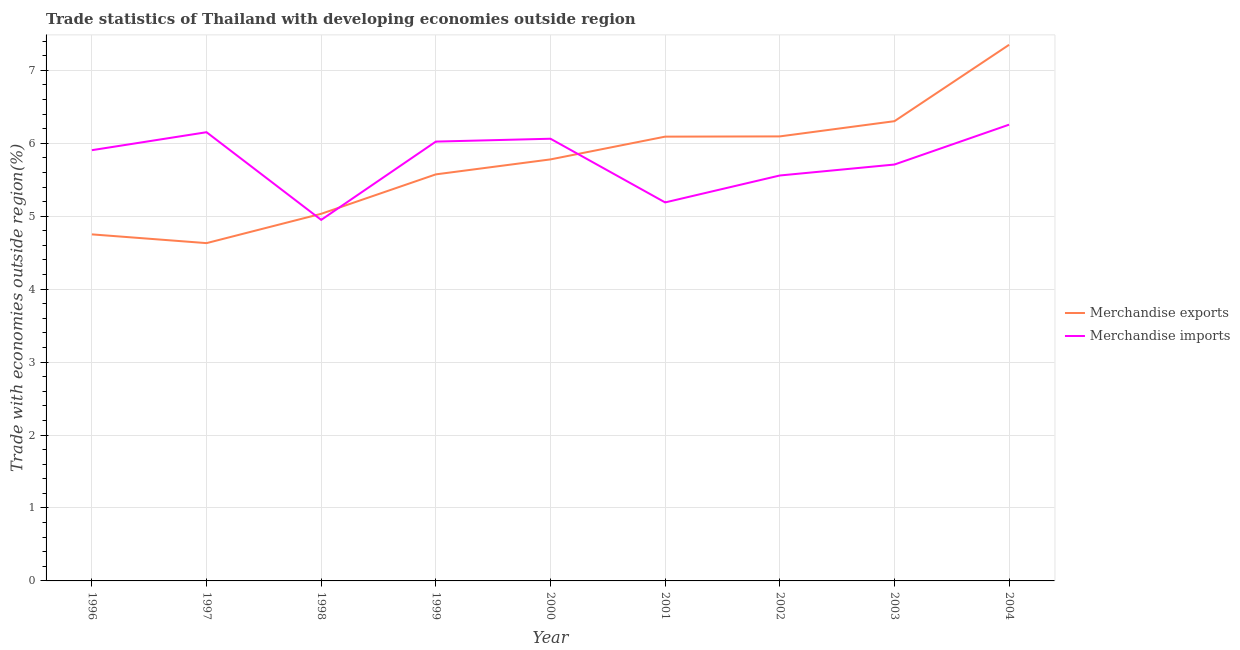How many different coloured lines are there?
Provide a short and direct response. 2. What is the merchandise exports in 2003?
Offer a terse response. 6.3. Across all years, what is the maximum merchandise exports?
Keep it short and to the point. 7.35. Across all years, what is the minimum merchandise imports?
Your response must be concise. 4.95. In which year was the merchandise imports maximum?
Your answer should be very brief. 2004. What is the total merchandise imports in the graph?
Your answer should be compact. 51.8. What is the difference between the merchandise imports in 1998 and that in 2001?
Ensure brevity in your answer.  -0.24. What is the difference between the merchandise exports in 1998 and the merchandise imports in 2000?
Give a very brief answer. -1.03. What is the average merchandise exports per year?
Make the answer very short. 5.73. In the year 2002, what is the difference between the merchandise exports and merchandise imports?
Provide a succinct answer. 0.54. In how many years, is the merchandise exports greater than 0.8 %?
Ensure brevity in your answer.  9. What is the ratio of the merchandise exports in 1996 to that in 1999?
Offer a terse response. 0.85. What is the difference between the highest and the second highest merchandise imports?
Keep it short and to the point. 0.1. What is the difference between the highest and the lowest merchandise imports?
Keep it short and to the point. 1.31. In how many years, is the merchandise imports greater than the average merchandise imports taken over all years?
Ensure brevity in your answer.  5. Is the sum of the merchandise exports in 1996 and 2003 greater than the maximum merchandise imports across all years?
Provide a succinct answer. Yes. Does the merchandise imports monotonically increase over the years?
Ensure brevity in your answer.  No. Is the merchandise exports strictly greater than the merchandise imports over the years?
Your response must be concise. No. Are the values on the major ticks of Y-axis written in scientific E-notation?
Provide a short and direct response. No. What is the title of the graph?
Your response must be concise. Trade statistics of Thailand with developing economies outside region. What is the label or title of the X-axis?
Offer a terse response. Year. What is the label or title of the Y-axis?
Your answer should be compact. Trade with economies outside region(%). What is the Trade with economies outside region(%) in Merchandise exports in 1996?
Provide a succinct answer. 4.75. What is the Trade with economies outside region(%) in Merchandise imports in 1996?
Your response must be concise. 5.91. What is the Trade with economies outside region(%) of Merchandise exports in 1997?
Keep it short and to the point. 4.63. What is the Trade with economies outside region(%) in Merchandise imports in 1997?
Provide a succinct answer. 6.15. What is the Trade with economies outside region(%) in Merchandise exports in 1998?
Provide a short and direct response. 5.03. What is the Trade with economies outside region(%) in Merchandise imports in 1998?
Your answer should be very brief. 4.95. What is the Trade with economies outside region(%) in Merchandise exports in 1999?
Your response must be concise. 5.57. What is the Trade with economies outside region(%) of Merchandise imports in 1999?
Your response must be concise. 6.02. What is the Trade with economies outside region(%) in Merchandise exports in 2000?
Make the answer very short. 5.78. What is the Trade with economies outside region(%) of Merchandise imports in 2000?
Ensure brevity in your answer.  6.06. What is the Trade with economies outside region(%) in Merchandise exports in 2001?
Keep it short and to the point. 6.09. What is the Trade with economies outside region(%) of Merchandise imports in 2001?
Offer a terse response. 5.19. What is the Trade with economies outside region(%) of Merchandise exports in 2002?
Offer a terse response. 6.09. What is the Trade with economies outside region(%) of Merchandise imports in 2002?
Your answer should be compact. 5.56. What is the Trade with economies outside region(%) of Merchandise exports in 2003?
Offer a very short reply. 6.3. What is the Trade with economies outside region(%) of Merchandise imports in 2003?
Make the answer very short. 5.71. What is the Trade with economies outside region(%) in Merchandise exports in 2004?
Ensure brevity in your answer.  7.35. What is the Trade with economies outside region(%) in Merchandise imports in 2004?
Your answer should be very brief. 6.25. Across all years, what is the maximum Trade with economies outside region(%) in Merchandise exports?
Keep it short and to the point. 7.35. Across all years, what is the maximum Trade with economies outside region(%) in Merchandise imports?
Your answer should be very brief. 6.25. Across all years, what is the minimum Trade with economies outside region(%) in Merchandise exports?
Offer a terse response. 4.63. Across all years, what is the minimum Trade with economies outside region(%) of Merchandise imports?
Provide a succinct answer. 4.95. What is the total Trade with economies outside region(%) in Merchandise exports in the graph?
Provide a succinct answer. 51.61. What is the total Trade with economies outside region(%) of Merchandise imports in the graph?
Provide a short and direct response. 51.8. What is the difference between the Trade with economies outside region(%) of Merchandise exports in 1996 and that in 1997?
Offer a terse response. 0.12. What is the difference between the Trade with economies outside region(%) in Merchandise imports in 1996 and that in 1997?
Your response must be concise. -0.25. What is the difference between the Trade with economies outside region(%) in Merchandise exports in 1996 and that in 1998?
Make the answer very short. -0.28. What is the difference between the Trade with economies outside region(%) in Merchandise imports in 1996 and that in 1998?
Ensure brevity in your answer.  0.96. What is the difference between the Trade with economies outside region(%) in Merchandise exports in 1996 and that in 1999?
Keep it short and to the point. -0.82. What is the difference between the Trade with economies outside region(%) of Merchandise imports in 1996 and that in 1999?
Give a very brief answer. -0.12. What is the difference between the Trade with economies outside region(%) in Merchandise exports in 1996 and that in 2000?
Keep it short and to the point. -1.03. What is the difference between the Trade with economies outside region(%) of Merchandise imports in 1996 and that in 2000?
Provide a succinct answer. -0.16. What is the difference between the Trade with economies outside region(%) of Merchandise exports in 1996 and that in 2001?
Your answer should be very brief. -1.34. What is the difference between the Trade with economies outside region(%) of Merchandise imports in 1996 and that in 2001?
Provide a succinct answer. 0.72. What is the difference between the Trade with economies outside region(%) of Merchandise exports in 1996 and that in 2002?
Keep it short and to the point. -1.34. What is the difference between the Trade with economies outside region(%) in Merchandise imports in 1996 and that in 2002?
Your response must be concise. 0.35. What is the difference between the Trade with economies outside region(%) in Merchandise exports in 1996 and that in 2003?
Your answer should be very brief. -1.55. What is the difference between the Trade with economies outside region(%) of Merchandise imports in 1996 and that in 2003?
Make the answer very short. 0.2. What is the difference between the Trade with economies outside region(%) in Merchandise exports in 1996 and that in 2004?
Offer a terse response. -2.6. What is the difference between the Trade with economies outside region(%) in Merchandise imports in 1996 and that in 2004?
Your answer should be compact. -0.35. What is the difference between the Trade with economies outside region(%) of Merchandise exports in 1997 and that in 1998?
Offer a very short reply. -0.4. What is the difference between the Trade with economies outside region(%) of Merchandise imports in 1997 and that in 1998?
Offer a very short reply. 1.2. What is the difference between the Trade with economies outside region(%) of Merchandise exports in 1997 and that in 1999?
Offer a terse response. -0.94. What is the difference between the Trade with economies outside region(%) in Merchandise imports in 1997 and that in 1999?
Offer a very short reply. 0.13. What is the difference between the Trade with economies outside region(%) in Merchandise exports in 1997 and that in 2000?
Your response must be concise. -1.15. What is the difference between the Trade with economies outside region(%) of Merchandise imports in 1997 and that in 2000?
Your answer should be very brief. 0.09. What is the difference between the Trade with economies outside region(%) of Merchandise exports in 1997 and that in 2001?
Ensure brevity in your answer.  -1.46. What is the difference between the Trade with economies outside region(%) in Merchandise imports in 1997 and that in 2001?
Make the answer very short. 0.96. What is the difference between the Trade with economies outside region(%) of Merchandise exports in 1997 and that in 2002?
Your answer should be compact. -1.46. What is the difference between the Trade with economies outside region(%) in Merchandise imports in 1997 and that in 2002?
Make the answer very short. 0.59. What is the difference between the Trade with economies outside region(%) in Merchandise exports in 1997 and that in 2003?
Make the answer very short. -1.67. What is the difference between the Trade with economies outside region(%) in Merchandise imports in 1997 and that in 2003?
Provide a succinct answer. 0.44. What is the difference between the Trade with economies outside region(%) of Merchandise exports in 1997 and that in 2004?
Provide a short and direct response. -2.72. What is the difference between the Trade with economies outside region(%) in Merchandise imports in 1997 and that in 2004?
Provide a short and direct response. -0.1. What is the difference between the Trade with economies outside region(%) of Merchandise exports in 1998 and that in 1999?
Ensure brevity in your answer.  -0.54. What is the difference between the Trade with economies outside region(%) in Merchandise imports in 1998 and that in 1999?
Provide a short and direct response. -1.07. What is the difference between the Trade with economies outside region(%) of Merchandise exports in 1998 and that in 2000?
Keep it short and to the point. -0.75. What is the difference between the Trade with economies outside region(%) of Merchandise imports in 1998 and that in 2000?
Provide a short and direct response. -1.11. What is the difference between the Trade with economies outside region(%) of Merchandise exports in 1998 and that in 2001?
Your answer should be compact. -1.06. What is the difference between the Trade with economies outside region(%) in Merchandise imports in 1998 and that in 2001?
Offer a terse response. -0.24. What is the difference between the Trade with economies outside region(%) of Merchandise exports in 1998 and that in 2002?
Provide a succinct answer. -1.06. What is the difference between the Trade with economies outside region(%) of Merchandise imports in 1998 and that in 2002?
Your answer should be compact. -0.61. What is the difference between the Trade with economies outside region(%) in Merchandise exports in 1998 and that in 2003?
Ensure brevity in your answer.  -1.27. What is the difference between the Trade with economies outside region(%) in Merchandise imports in 1998 and that in 2003?
Offer a very short reply. -0.76. What is the difference between the Trade with economies outside region(%) of Merchandise exports in 1998 and that in 2004?
Offer a very short reply. -2.32. What is the difference between the Trade with economies outside region(%) in Merchandise imports in 1998 and that in 2004?
Your answer should be compact. -1.31. What is the difference between the Trade with economies outside region(%) of Merchandise exports in 1999 and that in 2000?
Keep it short and to the point. -0.21. What is the difference between the Trade with economies outside region(%) in Merchandise imports in 1999 and that in 2000?
Offer a very short reply. -0.04. What is the difference between the Trade with economies outside region(%) in Merchandise exports in 1999 and that in 2001?
Keep it short and to the point. -0.52. What is the difference between the Trade with economies outside region(%) in Merchandise imports in 1999 and that in 2001?
Your answer should be very brief. 0.83. What is the difference between the Trade with economies outside region(%) in Merchandise exports in 1999 and that in 2002?
Make the answer very short. -0.52. What is the difference between the Trade with economies outside region(%) of Merchandise imports in 1999 and that in 2002?
Offer a very short reply. 0.46. What is the difference between the Trade with economies outside region(%) of Merchandise exports in 1999 and that in 2003?
Provide a succinct answer. -0.73. What is the difference between the Trade with economies outside region(%) of Merchandise imports in 1999 and that in 2003?
Provide a succinct answer. 0.31. What is the difference between the Trade with economies outside region(%) of Merchandise exports in 1999 and that in 2004?
Your answer should be compact. -1.78. What is the difference between the Trade with economies outside region(%) in Merchandise imports in 1999 and that in 2004?
Ensure brevity in your answer.  -0.23. What is the difference between the Trade with economies outside region(%) of Merchandise exports in 2000 and that in 2001?
Your answer should be compact. -0.31. What is the difference between the Trade with economies outside region(%) in Merchandise imports in 2000 and that in 2001?
Your answer should be compact. 0.87. What is the difference between the Trade with economies outside region(%) in Merchandise exports in 2000 and that in 2002?
Give a very brief answer. -0.32. What is the difference between the Trade with economies outside region(%) in Merchandise imports in 2000 and that in 2002?
Ensure brevity in your answer.  0.5. What is the difference between the Trade with economies outside region(%) of Merchandise exports in 2000 and that in 2003?
Provide a succinct answer. -0.52. What is the difference between the Trade with economies outside region(%) in Merchandise imports in 2000 and that in 2003?
Give a very brief answer. 0.35. What is the difference between the Trade with economies outside region(%) in Merchandise exports in 2000 and that in 2004?
Give a very brief answer. -1.57. What is the difference between the Trade with economies outside region(%) in Merchandise imports in 2000 and that in 2004?
Offer a terse response. -0.19. What is the difference between the Trade with economies outside region(%) of Merchandise exports in 2001 and that in 2002?
Your response must be concise. -0. What is the difference between the Trade with economies outside region(%) of Merchandise imports in 2001 and that in 2002?
Ensure brevity in your answer.  -0.37. What is the difference between the Trade with economies outside region(%) of Merchandise exports in 2001 and that in 2003?
Provide a succinct answer. -0.21. What is the difference between the Trade with economies outside region(%) in Merchandise imports in 2001 and that in 2003?
Your response must be concise. -0.52. What is the difference between the Trade with economies outside region(%) of Merchandise exports in 2001 and that in 2004?
Your response must be concise. -1.26. What is the difference between the Trade with economies outside region(%) in Merchandise imports in 2001 and that in 2004?
Provide a short and direct response. -1.07. What is the difference between the Trade with economies outside region(%) in Merchandise exports in 2002 and that in 2003?
Your response must be concise. -0.21. What is the difference between the Trade with economies outside region(%) in Merchandise imports in 2002 and that in 2003?
Your answer should be very brief. -0.15. What is the difference between the Trade with economies outside region(%) of Merchandise exports in 2002 and that in 2004?
Keep it short and to the point. -1.26. What is the difference between the Trade with economies outside region(%) in Merchandise imports in 2002 and that in 2004?
Give a very brief answer. -0.7. What is the difference between the Trade with economies outside region(%) of Merchandise exports in 2003 and that in 2004?
Your answer should be compact. -1.05. What is the difference between the Trade with economies outside region(%) of Merchandise imports in 2003 and that in 2004?
Your answer should be compact. -0.55. What is the difference between the Trade with economies outside region(%) of Merchandise exports in 1996 and the Trade with economies outside region(%) of Merchandise imports in 1997?
Provide a short and direct response. -1.4. What is the difference between the Trade with economies outside region(%) of Merchandise exports in 1996 and the Trade with economies outside region(%) of Merchandise imports in 1998?
Provide a short and direct response. -0.2. What is the difference between the Trade with economies outside region(%) in Merchandise exports in 1996 and the Trade with economies outside region(%) in Merchandise imports in 1999?
Provide a succinct answer. -1.27. What is the difference between the Trade with economies outside region(%) of Merchandise exports in 1996 and the Trade with economies outside region(%) of Merchandise imports in 2000?
Keep it short and to the point. -1.31. What is the difference between the Trade with economies outside region(%) of Merchandise exports in 1996 and the Trade with economies outside region(%) of Merchandise imports in 2001?
Offer a very short reply. -0.44. What is the difference between the Trade with economies outside region(%) in Merchandise exports in 1996 and the Trade with economies outside region(%) in Merchandise imports in 2002?
Your response must be concise. -0.81. What is the difference between the Trade with economies outside region(%) in Merchandise exports in 1996 and the Trade with economies outside region(%) in Merchandise imports in 2003?
Offer a very short reply. -0.96. What is the difference between the Trade with economies outside region(%) in Merchandise exports in 1996 and the Trade with economies outside region(%) in Merchandise imports in 2004?
Give a very brief answer. -1.5. What is the difference between the Trade with economies outside region(%) in Merchandise exports in 1997 and the Trade with economies outside region(%) in Merchandise imports in 1998?
Your answer should be compact. -0.32. What is the difference between the Trade with economies outside region(%) in Merchandise exports in 1997 and the Trade with economies outside region(%) in Merchandise imports in 1999?
Provide a short and direct response. -1.39. What is the difference between the Trade with economies outside region(%) of Merchandise exports in 1997 and the Trade with economies outside region(%) of Merchandise imports in 2000?
Offer a terse response. -1.43. What is the difference between the Trade with economies outside region(%) of Merchandise exports in 1997 and the Trade with economies outside region(%) of Merchandise imports in 2001?
Your answer should be compact. -0.56. What is the difference between the Trade with economies outside region(%) of Merchandise exports in 1997 and the Trade with economies outside region(%) of Merchandise imports in 2002?
Offer a very short reply. -0.93. What is the difference between the Trade with economies outside region(%) in Merchandise exports in 1997 and the Trade with economies outside region(%) in Merchandise imports in 2003?
Make the answer very short. -1.08. What is the difference between the Trade with economies outside region(%) of Merchandise exports in 1997 and the Trade with economies outside region(%) of Merchandise imports in 2004?
Provide a short and direct response. -1.62. What is the difference between the Trade with economies outside region(%) in Merchandise exports in 1998 and the Trade with economies outside region(%) in Merchandise imports in 1999?
Provide a short and direct response. -0.99. What is the difference between the Trade with economies outside region(%) in Merchandise exports in 1998 and the Trade with economies outside region(%) in Merchandise imports in 2000?
Your response must be concise. -1.03. What is the difference between the Trade with economies outside region(%) of Merchandise exports in 1998 and the Trade with economies outside region(%) of Merchandise imports in 2001?
Your answer should be compact. -0.16. What is the difference between the Trade with economies outside region(%) of Merchandise exports in 1998 and the Trade with economies outside region(%) of Merchandise imports in 2002?
Ensure brevity in your answer.  -0.53. What is the difference between the Trade with economies outside region(%) in Merchandise exports in 1998 and the Trade with economies outside region(%) in Merchandise imports in 2003?
Offer a terse response. -0.68. What is the difference between the Trade with economies outside region(%) in Merchandise exports in 1998 and the Trade with economies outside region(%) in Merchandise imports in 2004?
Ensure brevity in your answer.  -1.22. What is the difference between the Trade with economies outside region(%) in Merchandise exports in 1999 and the Trade with economies outside region(%) in Merchandise imports in 2000?
Provide a succinct answer. -0.49. What is the difference between the Trade with economies outside region(%) of Merchandise exports in 1999 and the Trade with economies outside region(%) of Merchandise imports in 2001?
Keep it short and to the point. 0.38. What is the difference between the Trade with economies outside region(%) of Merchandise exports in 1999 and the Trade with economies outside region(%) of Merchandise imports in 2002?
Your answer should be very brief. 0.02. What is the difference between the Trade with economies outside region(%) in Merchandise exports in 1999 and the Trade with economies outside region(%) in Merchandise imports in 2003?
Offer a very short reply. -0.13. What is the difference between the Trade with economies outside region(%) in Merchandise exports in 1999 and the Trade with economies outside region(%) in Merchandise imports in 2004?
Offer a very short reply. -0.68. What is the difference between the Trade with economies outside region(%) in Merchandise exports in 2000 and the Trade with economies outside region(%) in Merchandise imports in 2001?
Offer a terse response. 0.59. What is the difference between the Trade with economies outside region(%) of Merchandise exports in 2000 and the Trade with economies outside region(%) of Merchandise imports in 2002?
Keep it short and to the point. 0.22. What is the difference between the Trade with economies outside region(%) of Merchandise exports in 2000 and the Trade with economies outside region(%) of Merchandise imports in 2003?
Provide a succinct answer. 0.07. What is the difference between the Trade with economies outside region(%) of Merchandise exports in 2000 and the Trade with economies outside region(%) of Merchandise imports in 2004?
Ensure brevity in your answer.  -0.48. What is the difference between the Trade with economies outside region(%) of Merchandise exports in 2001 and the Trade with economies outside region(%) of Merchandise imports in 2002?
Offer a very short reply. 0.53. What is the difference between the Trade with economies outside region(%) in Merchandise exports in 2001 and the Trade with economies outside region(%) in Merchandise imports in 2003?
Your answer should be compact. 0.38. What is the difference between the Trade with economies outside region(%) in Merchandise exports in 2001 and the Trade with economies outside region(%) in Merchandise imports in 2004?
Your answer should be compact. -0.16. What is the difference between the Trade with economies outside region(%) of Merchandise exports in 2002 and the Trade with economies outside region(%) of Merchandise imports in 2003?
Provide a short and direct response. 0.39. What is the difference between the Trade with economies outside region(%) in Merchandise exports in 2002 and the Trade with economies outside region(%) in Merchandise imports in 2004?
Your response must be concise. -0.16. What is the difference between the Trade with economies outside region(%) in Merchandise exports in 2003 and the Trade with economies outside region(%) in Merchandise imports in 2004?
Your answer should be compact. 0.05. What is the average Trade with economies outside region(%) of Merchandise exports per year?
Offer a terse response. 5.73. What is the average Trade with economies outside region(%) of Merchandise imports per year?
Keep it short and to the point. 5.76. In the year 1996, what is the difference between the Trade with economies outside region(%) of Merchandise exports and Trade with economies outside region(%) of Merchandise imports?
Ensure brevity in your answer.  -1.15. In the year 1997, what is the difference between the Trade with economies outside region(%) in Merchandise exports and Trade with economies outside region(%) in Merchandise imports?
Your response must be concise. -1.52. In the year 1998, what is the difference between the Trade with economies outside region(%) in Merchandise exports and Trade with economies outside region(%) in Merchandise imports?
Your answer should be compact. 0.08. In the year 1999, what is the difference between the Trade with economies outside region(%) in Merchandise exports and Trade with economies outside region(%) in Merchandise imports?
Ensure brevity in your answer.  -0.45. In the year 2000, what is the difference between the Trade with economies outside region(%) in Merchandise exports and Trade with economies outside region(%) in Merchandise imports?
Your response must be concise. -0.28. In the year 2001, what is the difference between the Trade with economies outside region(%) of Merchandise exports and Trade with economies outside region(%) of Merchandise imports?
Give a very brief answer. 0.9. In the year 2002, what is the difference between the Trade with economies outside region(%) in Merchandise exports and Trade with economies outside region(%) in Merchandise imports?
Ensure brevity in your answer.  0.54. In the year 2003, what is the difference between the Trade with economies outside region(%) in Merchandise exports and Trade with economies outside region(%) in Merchandise imports?
Provide a succinct answer. 0.59. In the year 2004, what is the difference between the Trade with economies outside region(%) in Merchandise exports and Trade with economies outside region(%) in Merchandise imports?
Keep it short and to the point. 1.1. What is the ratio of the Trade with economies outside region(%) in Merchandise exports in 1996 to that in 1997?
Offer a very short reply. 1.03. What is the ratio of the Trade with economies outside region(%) of Merchandise exports in 1996 to that in 1998?
Provide a short and direct response. 0.94. What is the ratio of the Trade with economies outside region(%) of Merchandise imports in 1996 to that in 1998?
Keep it short and to the point. 1.19. What is the ratio of the Trade with economies outside region(%) of Merchandise exports in 1996 to that in 1999?
Your answer should be compact. 0.85. What is the ratio of the Trade with economies outside region(%) in Merchandise imports in 1996 to that in 1999?
Ensure brevity in your answer.  0.98. What is the ratio of the Trade with economies outside region(%) in Merchandise exports in 1996 to that in 2000?
Give a very brief answer. 0.82. What is the ratio of the Trade with economies outside region(%) in Merchandise imports in 1996 to that in 2000?
Your answer should be compact. 0.97. What is the ratio of the Trade with economies outside region(%) of Merchandise exports in 1996 to that in 2001?
Ensure brevity in your answer.  0.78. What is the ratio of the Trade with economies outside region(%) in Merchandise imports in 1996 to that in 2001?
Offer a very short reply. 1.14. What is the ratio of the Trade with economies outside region(%) in Merchandise exports in 1996 to that in 2002?
Keep it short and to the point. 0.78. What is the ratio of the Trade with economies outside region(%) of Merchandise imports in 1996 to that in 2002?
Offer a terse response. 1.06. What is the ratio of the Trade with economies outside region(%) of Merchandise exports in 1996 to that in 2003?
Your answer should be very brief. 0.75. What is the ratio of the Trade with economies outside region(%) in Merchandise imports in 1996 to that in 2003?
Ensure brevity in your answer.  1.03. What is the ratio of the Trade with economies outside region(%) in Merchandise exports in 1996 to that in 2004?
Your answer should be very brief. 0.65. What is the ratio of the Trade with economies outside region(%) of Merchandise imports in 1996 to that in 2004?
Make the answer very short. 0.94. What is the ratio of the Trade with economies outside region(%) of Merchandise exports in 1997 to that in 1998?
Your answer should be very brief. 0.92. What is the ratio of the Trade with economies outside region(%) of Merchandise imports in 1997 to that in 1998?
Keep it short and to the point. 1.24. What is the ratio of the Trade with economies outside region(%) of Merchandise exports in 1997 to that in 1999?
Ensure brevity in your answer.  0.83. What is the ratio of the Trade with economies outside region(%) of Merchandise imports in 1997 to that in 1999?
Your answer should be compact. 1.02. What is the ratio of the Trade with economies outside region(%) of Merchandise exports in 1997 to that in 2000?
Provide a short and direct response. 0.8. What is the ratio of the Trade with economies outside region(%) of Merchandise imports in 1997 to that in 2000?
Provide a short and direct response. 1.01. What is the ratio of the Trade with economies outside region(%) in Merchandise exports in 1997 to that in 2001?
Give a very brief answer. 0.76. What is the ratio of the Trade with economies outside region(%) of Merchandise imports in 1997 to that in 2001?
Offer a terse response. 1.19. What is the ratio of the Trade with economies outside region(%) in Merchandise exports in 1997 to that in 2002?
Make the answer very short. 0.76. What is the ratio of the Trade with economies outside region(%) in Merchandise imports in 1997 to that in 2002?
Give a very brief answer. 1.11. What is the ratio of the Trade with economies outside region(%) in Merchandise exports in 1997 to that in 2003?
Keep it short and to the point. 0.73. What is the ratio of the Trade with economies outside region(%) of Merchandise imports in 1997 to that in 2003?
Provide a short and direct response. 1.08. What is the ratio of the Trade with economies outside region(%) in Merchandise exports in 1997 to that in 2004?
Offer a very short reply. 0.63. What is the ratio of the Trade with economies outside region(%) in Merchandise imports in 1997 to that in 2004?
Make the answer very short. 0.98. What is the ratio of the Trade with economies outside region(%) in Merchandise exports in 1998 to that in 1999?
Your answer should be very brief. 0.9. What is the ratio of the Trade with economies outside region(%) of Merchandise imports in 1998 to that in 1999?
Keep it short and to the point. 0.82. What is the ratio of the Trade with economies outside region(%) in Merchandise exports in 1998 to that in 2000?
Provide a short and direct response. 0.87. What is the ratio of the Trade with economies outside region(%) in Merchandise imports in 1998 to that in 2000?
Offer a terse response. 0.82. What is the ratio of the Trade with economies outside region(%) in Merchandise exports in 1998 to that in 2001?
Offer a very short reply. 0.83. What is the ratio of the Trade with economies outside region(%) of Merchandise imports in 1998 to that in 2001?
Your answer should be compact. 0.95. What is the ratio of the Trade with economies outside region(%) in Merchandise exports in 1998 to that in 2002?
Your answer should be compact. 0.83. What is the ratio of the Trade with economies outside region(%) in Merchandise imports in 1998 to that in 2002?
Your response must be concise. 0.89. What is the ratio of the Trade with economies outside region(%) in Merchandise exports in 1998 to that in 2003?
Your response must be concise. 0.8. What is the ratio of the Trade with economies outside region(%) of Merchandise imports in 1998 to that in 2003?
Give a very brief answer. 0.87. What is the ratio of the Trade with economies outside region(%) in Merchandise exports in 1998 to that in 2004?
Provide a succinct answer. 0.68. What is the ratio of the Trade with economies outside region(%) of Merchandise imports in 1998 to that in 2004?
Make the answer very short. 0.79. What is the ratio of the Trade with economies outside region(%) of Merchandise exports in 1999 to that in 2000?
Provide a succinct answer. 0.96. What is the ratio of the Trade with economies outside region(%) of Merchandise exports in 1999 to that in 2001?
Offer a very short reply. 0.92. What is the ratio of the Trade with economies outside region(%) in Merchandise imports in 1999 to that in 2001?
Provide a succinct answer. 1.16. What is the ratio of the Trade with economies outside region(%) of Merchandise exports in 1999 to that in 2002?
Provide a succinct answer. 0.91. What is the ratio of the Trade with economies outside region(%) of Merchandise imports in 1999 to that in 2002?
Ensure brevity in your answer.  1.08. What is the ratio of the Trade with economies outside region(%) of Merchandise exports in 1999 to that in 2003?
Make the answer very short. 0.88. What is the ratio of the Trade with economies outside region(%) of Merchandise imports in 1999 to that in 2003?
Provide a short and direct response. 1.06. What is the ratio of the Trade with economies outside region(%) of Merchandise exports in 1999 to that in 2004?
Keep it short and to the point. 0.76. What is the ratio of the Trade with economies outside region(%) in Merchandise imports in 1999 to that in 2004?
Give a very brief answer. 0.96. What is the ratio of the Trade with economies outside region(%) in Merchandise exports in 2000 to that in 2001?
Keep it short and to the point. 0.95. What is the ratio of the Trade with economies outside region(%) in Merchandise imports in 2000 to that in 2001?
Ensure brevity in your answer.  1.17. What is the ratio of the Trade with economies outside region(%) of Merchandise exports in 2000 to that in 2002?
Offer a terse response. 0.95. What is the ratio of the Trade with economies outside region(%) of Merchandise imports in 2000 to that in 2002?
Your answer should be very brief. 1.09. What is the ratio of the Trade with economies outside region(%) of Merchandise exports in 2000 to that in 2003?
Ensure brevity in your answer.  0.92. What is the ratio of the Trade with economies outside region(%) of Merchandise imports in 2000 to that in 2003?
Your answer should be very brief. 1.06. What is the ratio of the Trade with economies outside region(%) in Merchandise exports in 2000 to that in 2004?
Ensure brevity in your answer.  0.79. What is the ratio of the Trade with economies outside region(%) in Merchandise imports in 2000 to that in 2004?
Offer a very short reply. 0.97. What is the ratio of the Trade with economies outside region(%) in Merchandise exports in 2001 to that in 2002?
Offer a terse response. 1. What is the ratio of the Trade with economies outside region(%) of Merchandise imports in 2001 to that in 2002?
Provide a succinct answer. 0.93. What is the ratio of the Trade with economies outside region(%) of Merchandise exports in 2001 to that in 2003?
Provide a short and direct response. 0.97. What is the ratio of the Trade with economies outside region(%) in Merchandise imports in 2001 to that in 2003?
Give a very brief answer. 0.91. What is the ratio of the Trade with economies outside region(%) of Merchandise exports in 2001 to that in 2004?
Provide a succinct answer. 0.83. What is the ratio of the Trade with economies outside region(%) in Merchandise imports in 2001 to that in 2004?
Make the answer very short. 0.83. What is the ratio of the Trade with economies outside region(%) in Merchandise exports in 2002 to that in 2003?
Offer a terse response. 0.97. What is the ratio of the Trade with economies outside region(%) of Merchandise imports in 2002 to that in 2003?
Give a very brief answer. 0.97. What is the ratio of the Trade with economies outside region(%) in Merchandise exports in 2002 to that in 2004?
Keep it short and to the point. 0.83. What is the ratio of the Trade with economies outside region(%) in Merchandise imports in 2002 to that in 2004?
Your answer should be compact. 0.89. What is the ratio of the Trade with economies outside region(%) in Merchandise exports in 2003 to that in 2004?
Offer a very short reply. 0.86. What is the ratio of the Trade with economies outside region(%) of Merchandise imports in 2003 to that in 2004?
Offer a terse response. 0.91. What is the difference between the highest and the second highest Trade with economies outside region(%) of Merchandise exports?
Your response must be concise. 1.05. What is the difference between the highest and the second highest Trade with economies outside region(%) in Merchandise imports?
Your response must be concise. 0.1. What is the difference between the highest and the lowest Trade with economies outside region(%) of Merchandise exports?
Offer a very short reply. 2.72. What is the difference between the highest and the lowest Trade with economies outside region(%) in Merchandise imports?
Make the answer very short. 1.31. 